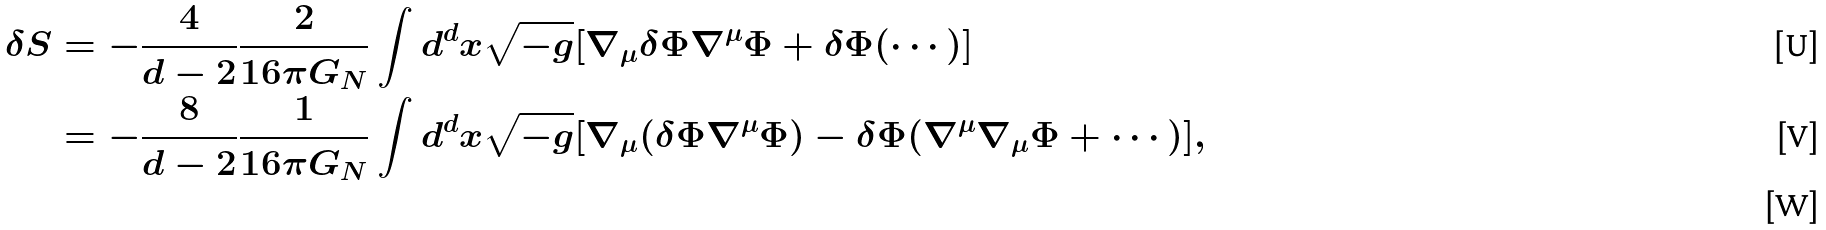Convert formula to latex. <formula><loc_0><loc_0><loc_500><loc_500>\delta S & = - \frac { 4 } { d - 2 } \frac { 2 } { 1 6 \pi G _ { N } } \int d ^ { d } x \sqrt { - g } [ \nabla _ { \mu } \delta \Phi \nabla ^ { \mu } \Phi + \delta \Phi ( \cdots ) ] \\ & = - \frac { 8 } { d - 2 } \frac { 1 } { 1 6 \pi G _ { N } } \int d ^ { d } x \sqrt { - g } [ \nabla _ { \mu } ( \delta \Phi \nabla ^ { \mu } \Phi ) - \delta \Phi ( \nabla ^ { \mu } \nabla _ { \mu } \Phi + \cdots ) ] , \\</formula> 